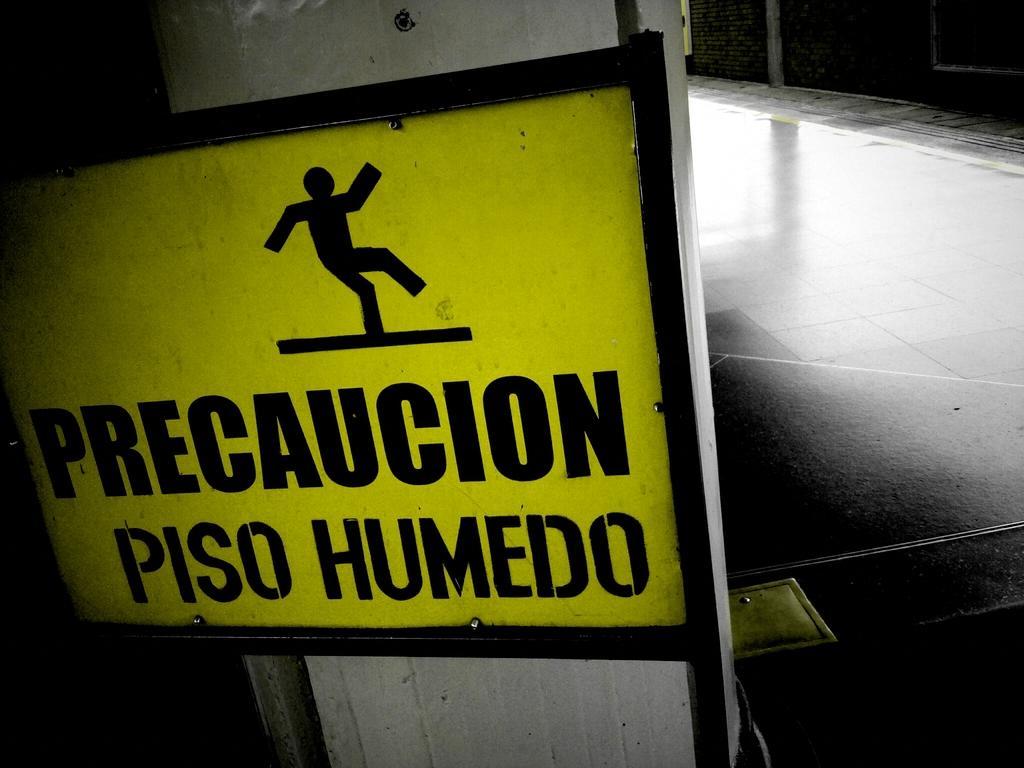Describe this image in one or two sentences. In this image there is a precaution board which is fixed to the pillar. On the right side there is a floor. 